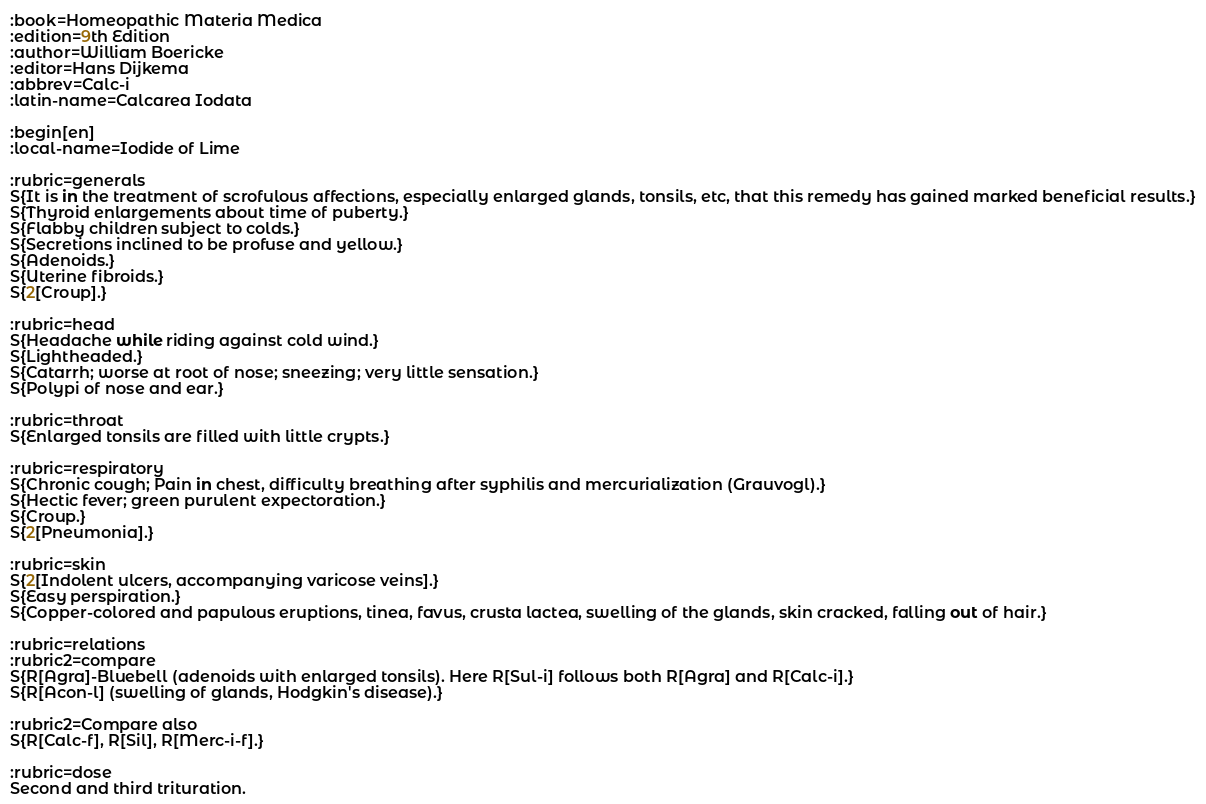Convert code to text. <code><loc_0><loc_0><loc_500><loc_500><_ObjectiveC_>:book=Homeopathic Materia Medica
:edition=9th Edition
:author=William Boericke
:editor=Hans Dijkema
:abbrev=Calc-i
:latin-name=Calcarea Iodata

:begin[en]
:local-name=Iodide of Lime

:rubric=generals
S{It is in the treatment of scrofulous affections, especially enlarged glands, tonsils, etc, that this remedy has gained marked beneficial results.}
S{Thyroid enlargements about time of puberty.}
S{Flabby children subject to colds.}
S{Secretions inclined to be profuse and yellow.}
S{Adenoids.}
S{Uterine fibroids.}
S{2[Croup].}

:rubric=head
S{Headache while riding against cold wind.}
S{Lightheaded.}
S{Catarrh; worse at root of nose; sneezing; very little sensation.}
S{Polypi of nose and ear.}

:rubric=throat
S{Enlarged tonsils are filled with little crypts.}

:rubric=respiratory
S{Chronic cough; Pain in chest, difficulty breathing after syphilis and mercurialization (Grauvogl).}
S{Hectic fever; green purulent expectoration.}
S{Croup.}
S{2[Pneumonia].}

:rubric=skin
S{2[Indolent ulcers, accompanying varicose veins].}
S{Easy perspiration.}
S{Copper-colored and papulous eruptions, tinea, favus, crusta lactea, swelling of the glands, skin cracked, falling out of hair.}

:rubric=relations
:rubric2=compare
S{R[Agra]-Bluebell (adenoids with enlarged tonsils). Here R[Sul-i] follows both R[Agra] and R[Calc-i].}
S{R[Acon-l] (swelling of glands, Hodgkin's disease).}

:rubric2=Compare also
S{R[Calc-f], R[Sil], R[Merc-i-f].}

:rubric=dose
Second and third trituration.</code> 